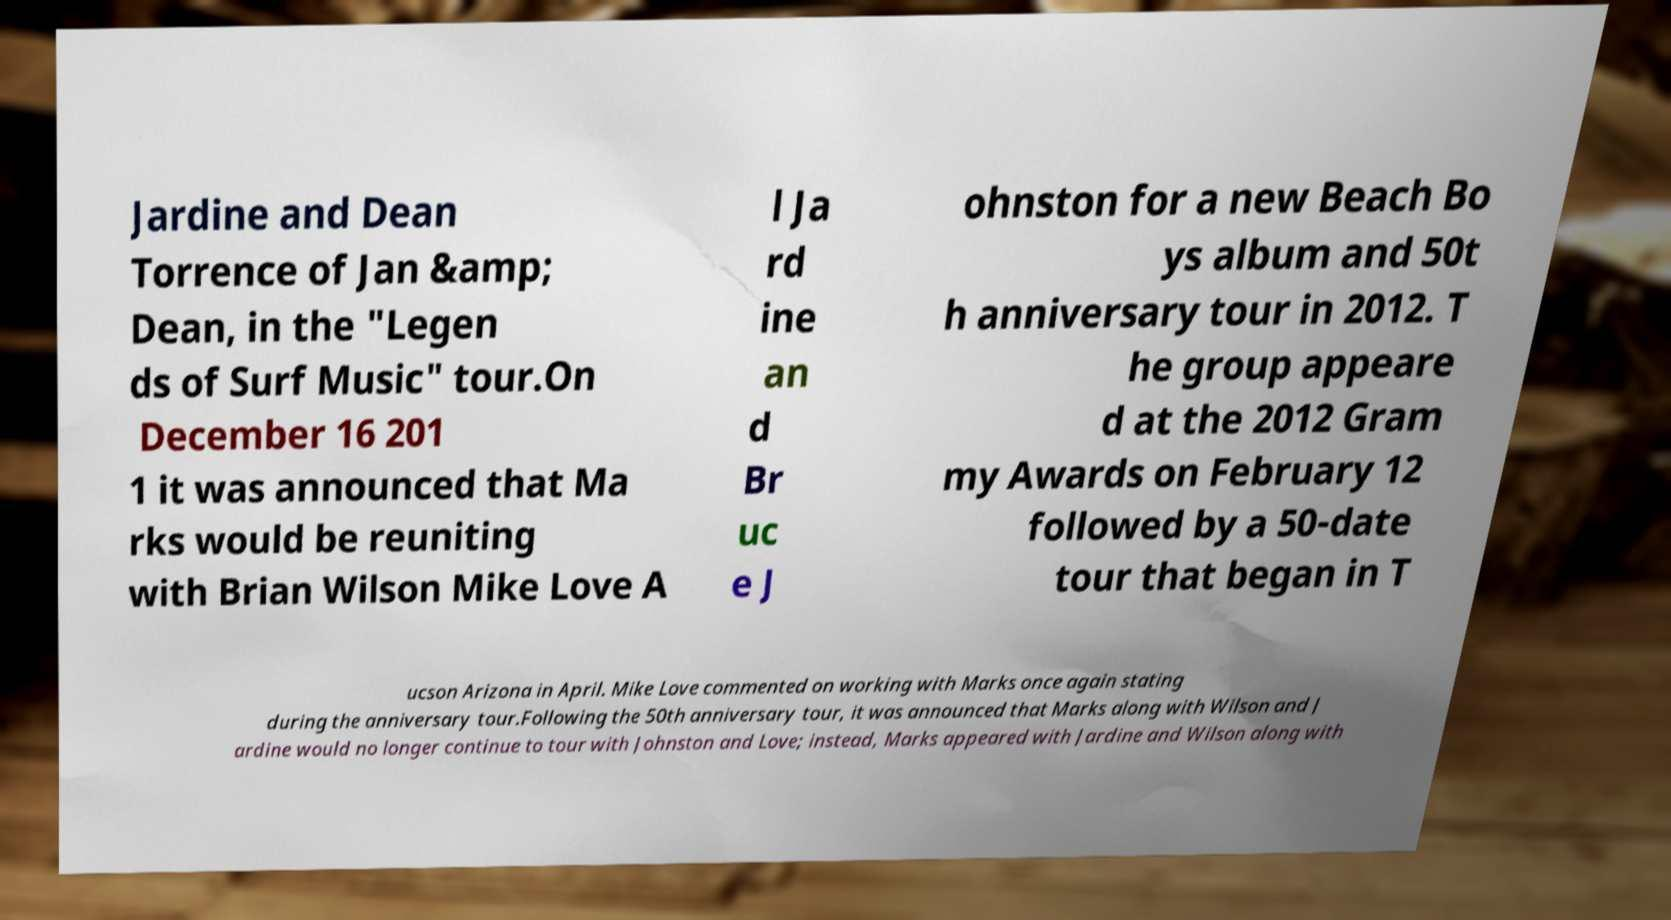There's text embedded in this image that I need extracted. Can you transcribe it verbatim? Jardine and Dean Torrence of Jan &amp; Dean, in the "Legen ds of Surf Music" tour.On December 16 201 1 it was announced that Ma rks would be reuniting with Brian Wilson Mike Love A l Ja rd ine an d Br uc e J ohnston for a new Beach Bo ys album and 50t h anniversary tour in 2012. T he group appeare d at the 2012 Gram my Awards on February 12 followed by a 50-date tour that began in T ucson Arizona in April. Mike Love commented on working with Marks once again stating during the anniversary tour.Following the 50th anniversary tour, it was announced that Marks along with Wilson and J ardine would no longer continue to tour with Johnston and Love; instead, Marks appeared with Jardine and Wilson along with 